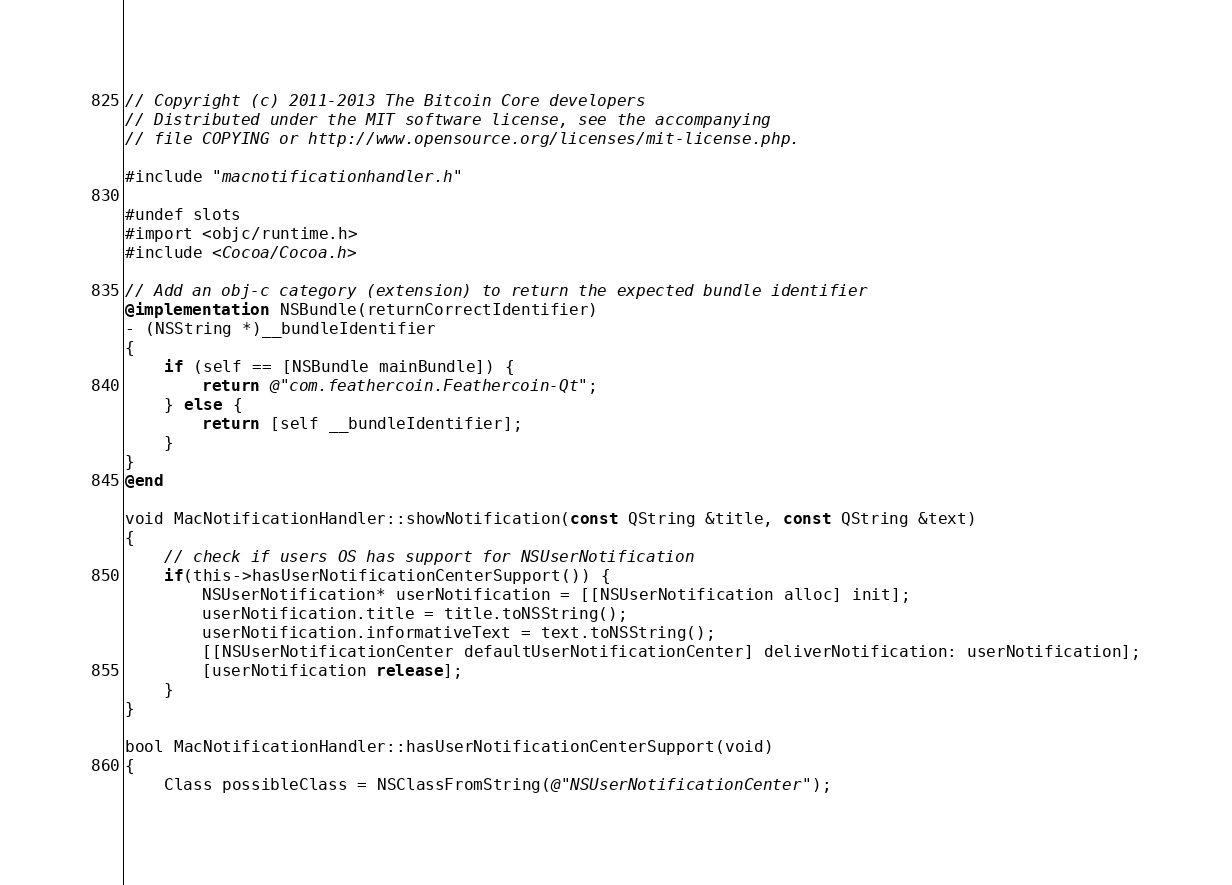<code> <loc_0><loc_0><loc_500><loc_500><_ObjectiveC_>// Copyright (c) 2011-2013 The Bitcoin Core developers
// Distributed under the MIT software license, see the accompanying
// file COPYING or http://www.opensource.org/licenses/mit-license.php.

#include "macnotificationhandler.h"

#undef slots
#import <objc/runtime.h>
#include <Cocoa/Cocoa.h>

// Add an obj-c category (extension) to return the expected bundle identifier
@implementation NSBundle(returnCorrectIdentifier)
- (NSString *)__bundleIdentifier
{
    if (self == [NSBundle mainBundle]) {
        return @"com.feathercoin.Feathercoin-Qt";
    } else {
        return [self __bundleIdentifier];
    }
}
@end

void MacNotificationHandler::showNotification(const QString &title, const QString &text)
{
    // check if users OS has support for NSUserNotification
    if(this->hasUserNotificationCenterSupport()) {
        NSUserNotification* userNotification = [[NSUserNotification alloc] init];
        userNotification.title = title.toNSString();
        userNotification.informativeText = text.toNSString();
        [[NSUserNotificationCenter defaultUserNotificationCenter] deliverNotification: userNotification];
        [userNotification release];
    }
}

bool MacNotificationHandler::hasUserNotificationCenterSupport(void)
{
    Class possibleClass = NSClassFromString(@"NSUserNotificationCenter");
</code> 